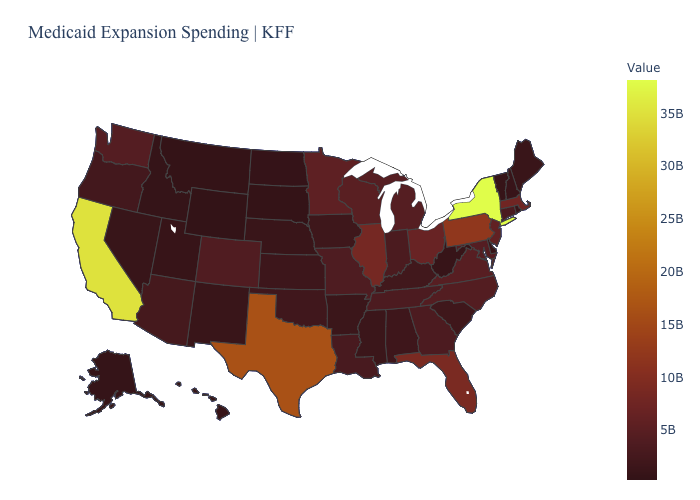Among the states that border Indiana , which have the highest value?
Be succinct. Illinois. Which states hav the highest value in the South?
Concise answer only. Texas. Which states have the highest value in the USA?
Concise answer only. New York. Does the map have missing data?
Concise answer only. No. Does the map have missing data?
Answer briefly. No. Does New York have the highest value in the USA?
Short answer required. Yes. Does Virginia have the lowest value in the South?
Write a very short answer. No. Among the states that border Colorado , does Arizona have the lowest value?
Write a very short answer. No. 